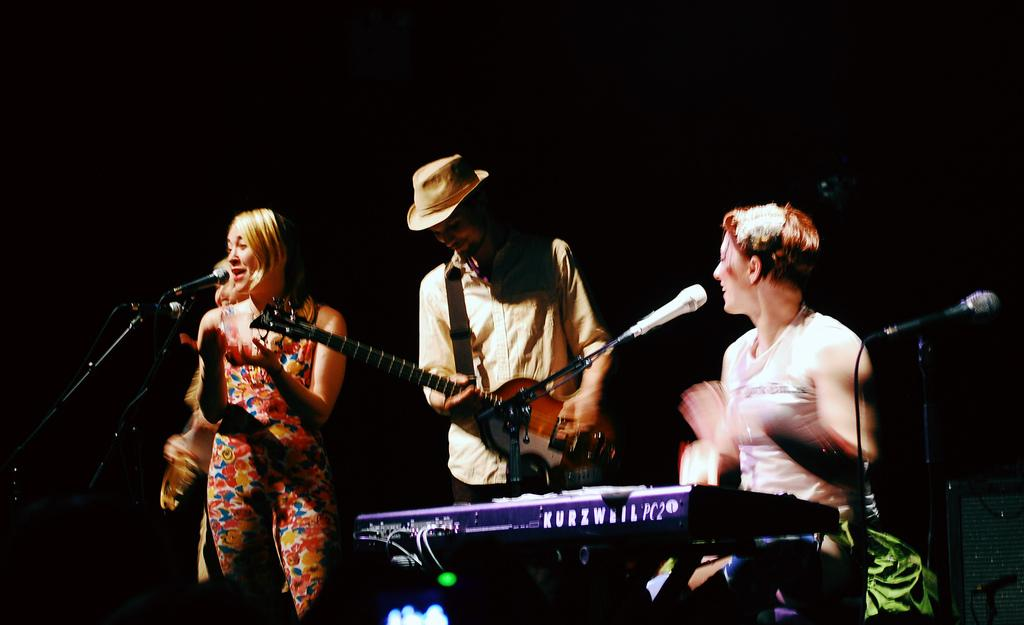How many people are in the image? There is a group of persons in the image. What are the persons in the image doing? The persons are playing musical instruments and singing together. What type of degree is the person holding in the image? There is no person holding a degree in the image; the persons are playing musical instruments and singing together. What kind of toys can be seen in the image? There are no toys present in the image. 